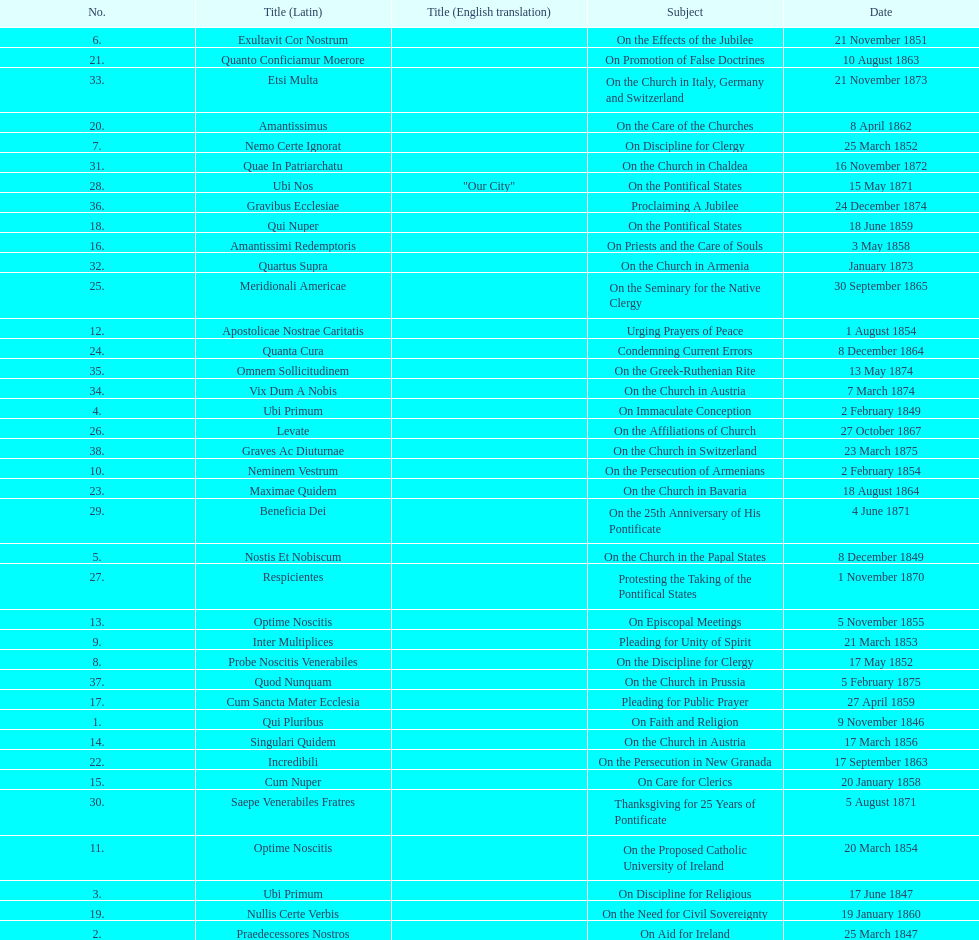How many subjects are there? 38. 